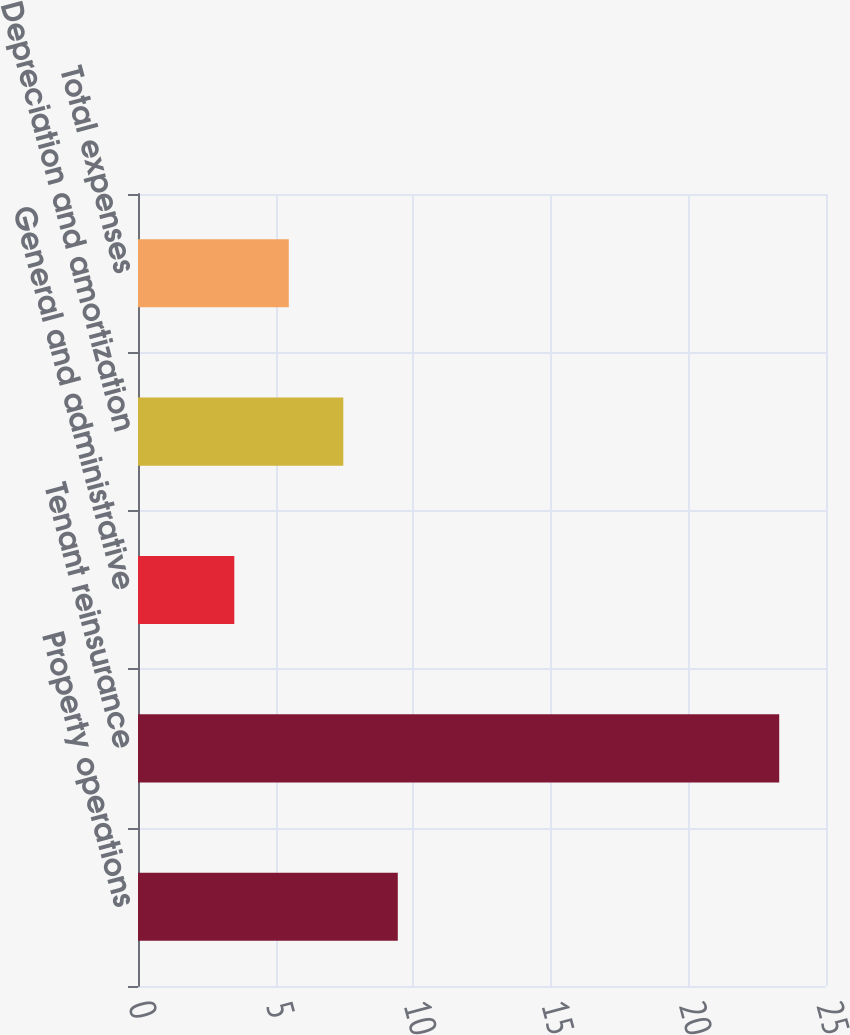Convert chart to OTSL. <chart><loc_0><loc_0><loc_500><loc_500><bar_chart><fcel>Property operations<fcel>Tenant reinsurance<fcel>General and administrative<fcel>Depreciation and amortization<fcel>Total expenses<nl><fcel>9.44<fcel>23.3<fcel>3.5<fcel>7.46<fcel>5.48<nl></chart> 